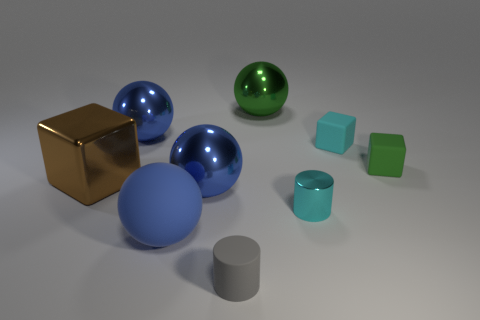Can you describe the different textures that are visible in this image? Certainly! The image showcases a variety of textures. There is a large golden cube with a reflective, matte surface. Nearby, you can see three spherical objects, two with a smooth, glossy metallic blue finish and one with a glossy metallic green finish. Additionally, there are several matte cylinders and cubes with what appears to be a soft, non-reflective surface in shades of blue and green. 